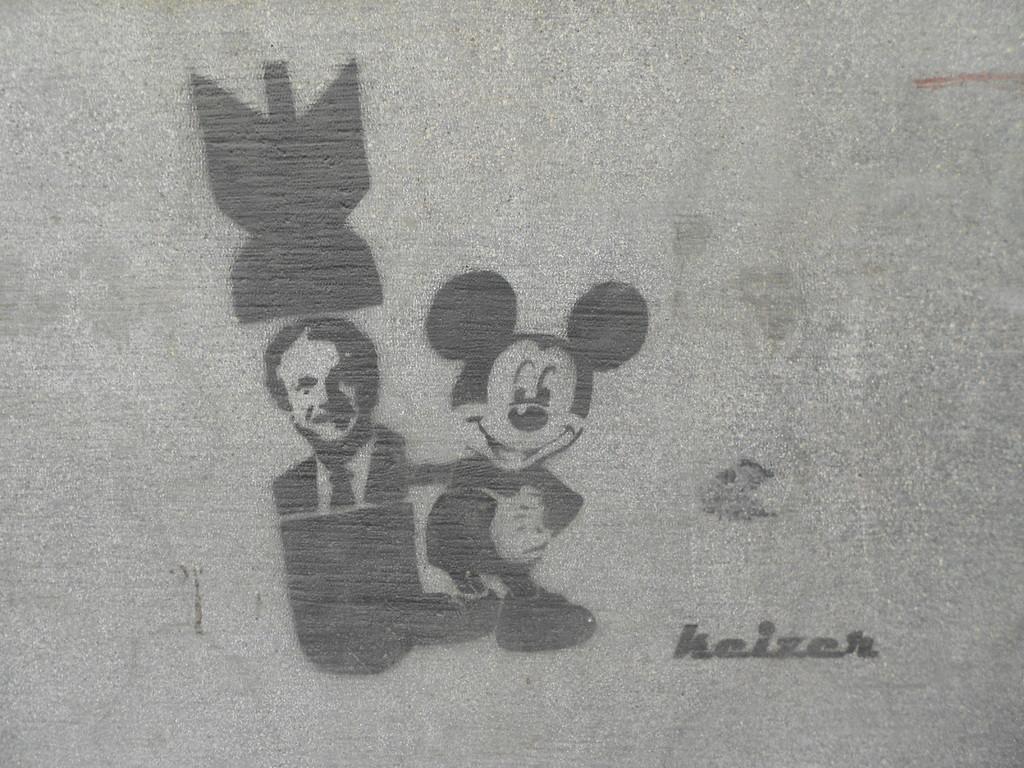Could you give a brief overview of what you see in this image? In this image, there is an art contains a person and mickey mouse. 